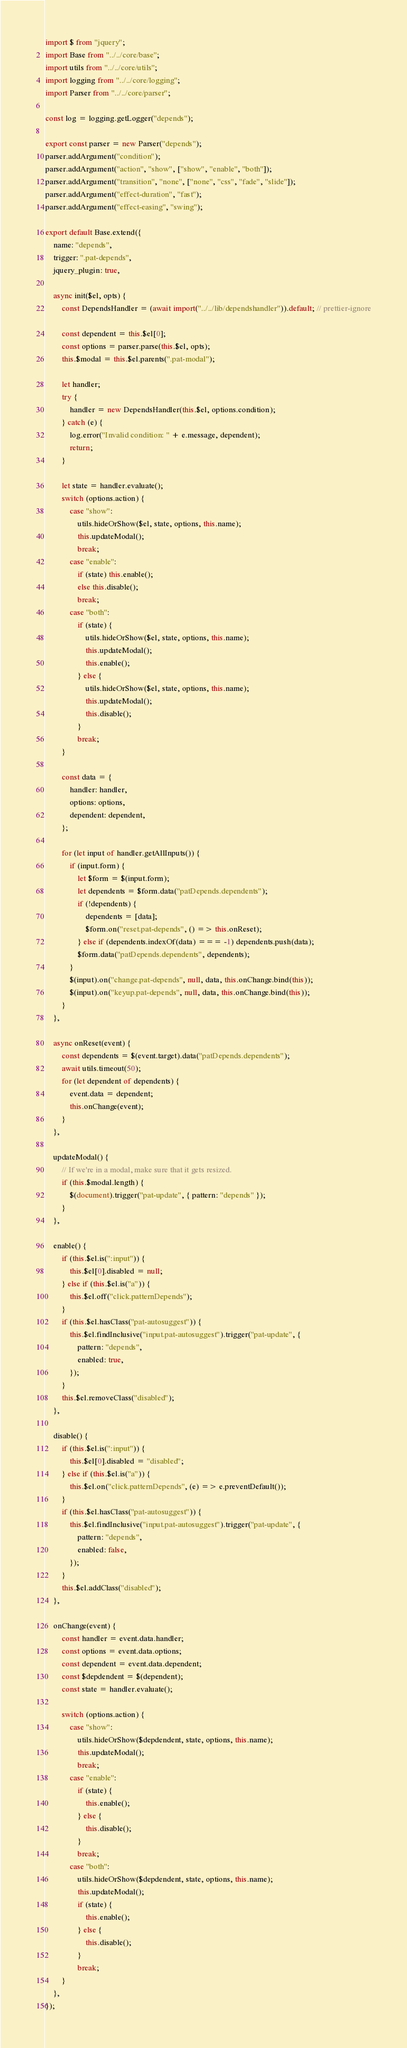<code> <loc_0><loc_0><loc_500><loc_500><_JavaScript_>import $ from "jquery";
import Base from "../../core/base";
import utils from "../../core/utils";
import logging from "../../core/logging";
import Parser from "../../core/parser";

const log = logging.getLogger("depends");

export const parser = new Parser("depends");
parser.addArgument("condition");
parser.addArgument("action", "show", ["show", "enable", "both"]);
parser.addArgument("transition", "none", ["none", "css", "fade", "slide"]);
parser.addArgument("effect-duration", "fast");
parser.addArgument("effect-easing", "swing");

export default Base.extend({
    name: "depends",
    trigger: ".pat-depends",
    jquery_plugin: true,

    async init($el, opts) {
        const DependsHandler = (await import("../../lib/dependshandler")).default; // prettier-ignore

        const dependent = this.$el[0];
        const options = parser.parse(this.$el, opts);
        this.$modal = this.$el.parents(".pat-modal");

        let handler;
        try {
            handler = new DependsHandler(this.$el, options.condition);
        } catch (e) {
            log.error("Invalid condition: " + e.message, dependent);
            return;
        }

        let state = handler.evaluate();
        switch (options.action) {
            case "show":
                utils.hideOrShow($el, state, options, this.name);
                this.updateModal();
                break;
            case "enable":
                if (state) this.enable();
                else this.disable();
                break;
            case "both":
                if (state) {
                    utils.hideOrShow($el, state, options, this.name);
                    this.updateModal();
                    this.enable();
                } else {
                    utils.hideOrShow($el, state, options, this.name);
                    this.updateModal();
                    this.disable();
                }
                break;
        }

        const data = {
            handler: handler,
            options: options,
            dependent: dependent,
        };

        for (let input of handler.getAllInputs()) {
            if (input.form) {
                let $form = $(input.form);
                let dependents = $form.data("patDepends.dependents");
                if (!dependents) {
                    dependents = [data];
                    $form.on("reset.pat-depends", () => this.onReset);
                } else if (dependents.indexOf(data) === -1) dependents.push(data);
                $form.data("patDepends.dependents", dependents);
            }
            $(input).on("change.pat-depends", null, data, this.onChange.bind(this));
            $(input).on("keyup.pat-depends", null, data, this.onChange.bind(this));
        }
    },

    async onReset(event) {
        const dependents = $(event.target).data("patDepends.dependents");
        await utils.timeout(50);
        for (let dependent of dependents) {
            event.data = dependent;
            this.onChange(event);
        }
    },

    updateModal() {
        // If we're in a modal, make sure that it gets resized.
        if (this.$modal.length) {
            $(document).trigger("pat-update", { pattern: "depends" });
        }
    },

    enable() {
        if (this.$el.is(":input")) {
            this.$el[0].disabled = null;
        } else if (this.$el.is("a")) {
            this.$el.off("click.patternDepends");
        }
        if (this.$el.hasClass("pat-autosuggest")) {
            this.$el.findInclusive("input.pat-autosuggest").trigger("pat-update", {
                pattern: "depends",
                enabled: true,
            });
        }
        this.$el.removeClass("disabled");
    },

    disable() {
        if (this.$el.is(":input")) {
            this.$el[0].disabled = "disabled";
        } else if (this.$el.is("a")) {
            this.$el.on("click.patternDepends", (e) => e.preventDefault());
        }
        if (this.$el.hasClass("pat-autosuggest")) {
            this.$el.findInclusive("input.pat-autosuggest").trigger("pat-update", {
                pattern: "depends",
                enabled: false,
            });
        }
        this.$el.addClass("disabled");
    },

    onChange(event) {
        const handler = event.data.handler;
        const options = event.data.options;
        const dependent = event.data.dependent;
        const $depdendent = $(dependent);
        const state = handler.evaluate();

        switch (options.action) {
            case "show":
                utils.hideOrShow($depdendent, state, options, this.name);
                this.updateModal();
                break;
            case "enable":
                if (state) {
                    this.enable();
                } else {
                    this.disable();
                }
                break;
            case "both":
                utils.hideOrShow($depdendent, state, options, this.name);
                this.updateModal();
                if (state) {
                    this.enable();
                } else {
                    this.disable();
                }
                break;
        }
    },
});
</code> 